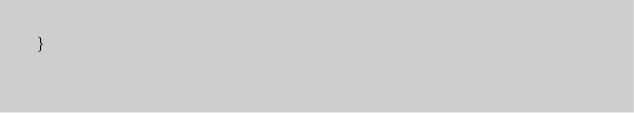<code> <loc_0><loc_0><loc_500><loc_500><_Java_>}
</code> 